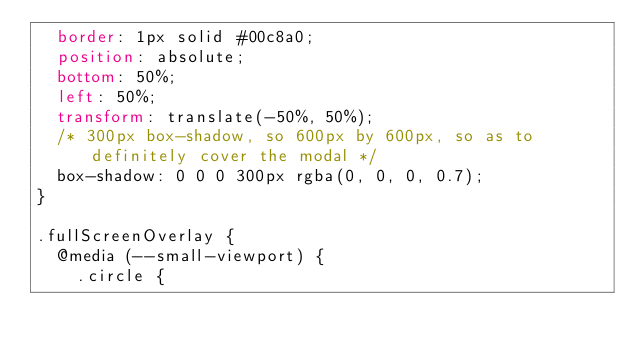Convert code to text. <code><loc_0><loc_0><loc_500><loc_500><_CSS_>  border: 1px solid #00c8a0;
  position: absolute;
  bottom: 50%;
  left: 50%;
  transform: translate(-50%, 50%);
  /* 300px box-shadow, so 600px by 600px, so as to definitely cover the modal */
  box-shadow: 0 0 0 300px rgba(0, 0, 0, 0.7);
}

.fullScreenOverlay {
  @media (--small-viewport) {
    .circle {</code> 